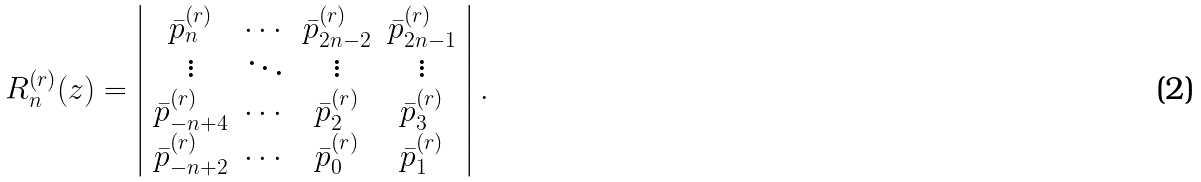Convert formula to latex. <formula><loc_0><loc_0><loc_500><loc_500>R _ { n } ^ { ( r ) } ( z ) = \left | \begin{array} { c c c c } \bar { p } _ { n } ^ { ( r ) } & \cdots & \bar { p } _ { 2 n - 2 } ^ { ( r ) } & \bar { p } _ { 2 n - 1 } ^ { ( r ) } \\ \vdots & \ddots & \vdots & \vdots \\ \bar { p } _ { - n + 4 } ^ { ( r ) } & \cdots & \bar { p } _ { 2 } ^ { ( r ) } & \bar { p } _ { 3 } ^ { ( r ) } \\ \bar { p } _ { - n + 2 } ^ { ( r ) } & \cdots & \bar { p } _ { 0 } ^ { ( r ) } & \bar { p } _ { 1 } ^ { ( r ) } \end{array} \right | .</formula> 